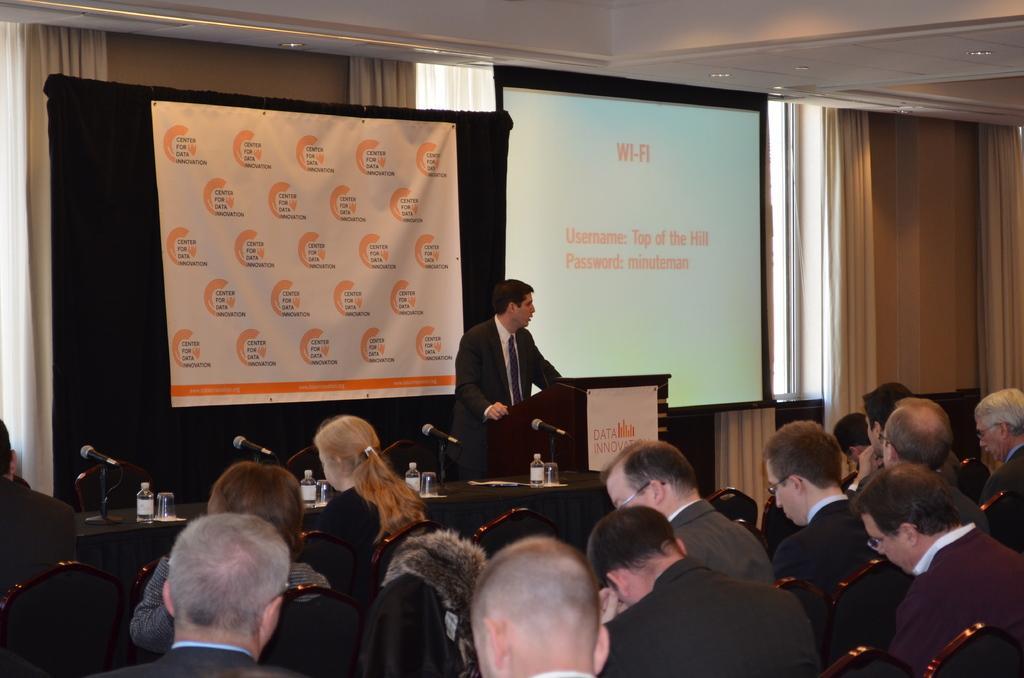Can you describe this image briefly? In this image, we can see a group of people. Few people are sitting on the chairs. Here a person is standing near the podium with sticker. Here there is a desk covered with cloth. Few things and objects are placed on it. Background we can see a banner, screen, wall, curtains. 